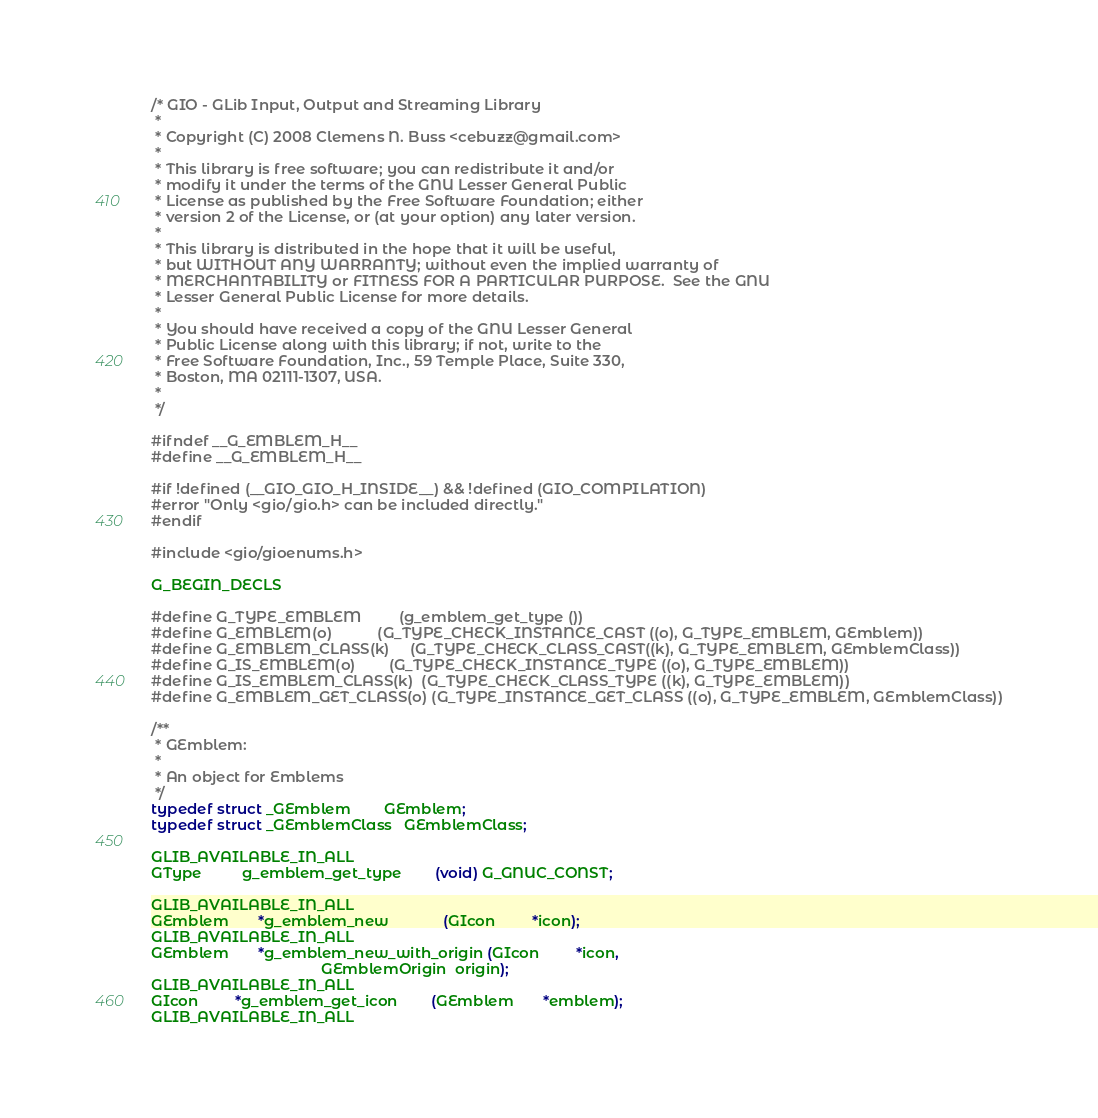Convert code to text. <code><loc_0><loc_0><loc_500><loc_500><_C_>/* GIO - GLib Input, Output and Streaming Library
 *
 * Copyright (C) 2008 Clemens N. Buss <cebuzz@gmail.com>
 *
 * This library is free software; you can redistribute it and/or
 * modify it under the terms of the GNU Lesser General Public
 * License as published by the Free Software Foundation; either
 * version 2 of the License, or (at your option) any later version.
 *
 * This library is distributed in the hope that it will be useful,
 * but WITHOUT ANY WARRANTY; without even the implied warranty of
 * MERCHANTABILITY or FITNESS FOR A PARTICULAR PURPOSE.  See the GNU
 * Lesser General Public License for more details.
 *
 * You should have received a copy of the GNU Lesser General
 * Public License along with this library; if not, write to the
 * Free Software Foundation, Inc., 59 Temple Place, Suite 330,
 * Boston, MA 02111-1307, USA.
 *
 */

#ifndef __G_EMBLEM_H__
#define __G_EMBLEM_H__

#if !defined (__GIO_GIO_H_INSIDE__) && !defined (GIO_COMPILATION)
#error "Only <gio/gio.h> can be included directly."
#endif

#include <gio/gioenums.h>

G_BEGIN_DECLS

#define G_TYPE_EMBLEM         (g_emblem_get_type ())
#define G_EMBLEM(o)           (G_TYPE_CHECK_INSTANCE_CAST ((o), G_TYPE_EMBLEM, GEmblem))
#define G_EMBLEM_CLASS(k)     (G_TYPE_CHECK_CLASS_CAST((k), G_TYPE_EMBLEM, GEmblemClass))
#define G_IS_EMBLEM(o)        (G_TYPE_CHECK_INSTANCE_TYPE ((o), G_TYPE_EMBLEM))
#define G_IS_EMBLEM_CLASS(k)  (G_TYPE_CHECK_CLASS_TYPE ((k), G_TYPE_EMBLEM))
#define G_EMBLEM_GET_CLASS(o) (G_TYPE_INSTANCE_GET_CLASS ((o), G_TYPE_EMBLEM, GEmblemClass))

/**
 * GEmblem:
 *
 * An object for Emblems
 */
typedef struct _GEmblem        GEmblem;
typedef struct _GEmblemClass   GEmblemClass;

GLIB_AVAILABLE_IN_ALL
GType          g_emblem_get_type        (void) G_GNUC_CONST;

GLIB_AVAILABLE_IN_ALL
GEmblem       *g_emblem_new             (GIcon         *icon);
GLIB_AVAILABLE_IN_ALL
GEmblem       *g_emblem_new_with_origin (GIcon         *icon,
                                         GEmblemOrigin  origin);
GLIB_AVAILABLE_IN_ALL
GIcon         *g_emblem_get_icon        (GEmblem       *emblem);
GLIB_AVAILABLE_IN_ALL</code> 